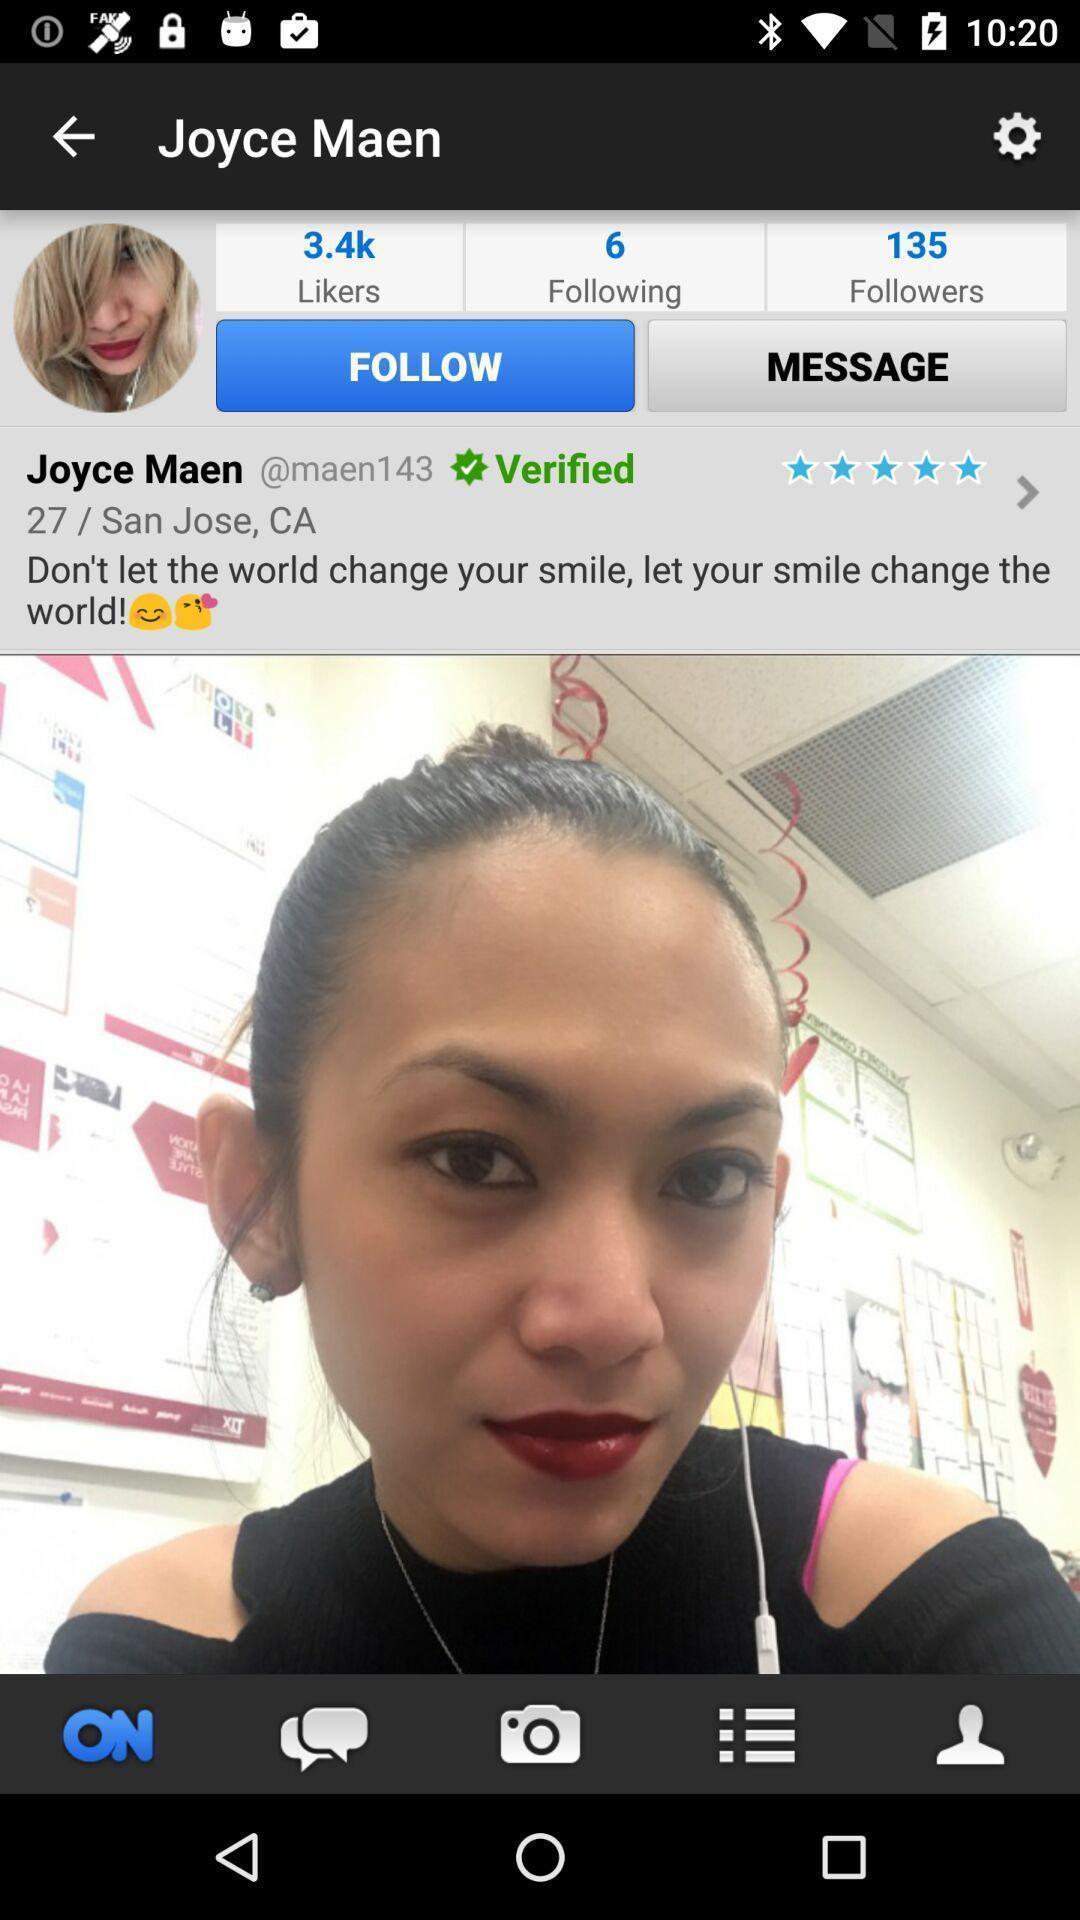Summarize the information in this screenshot. Profile page of a social media app. 